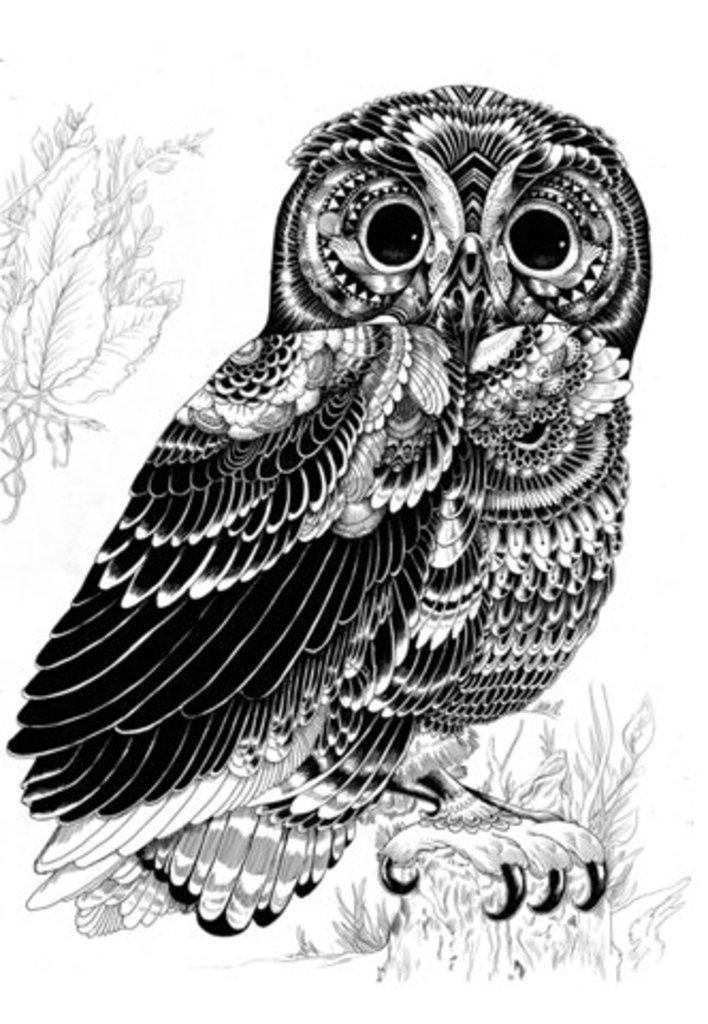Please provide a concise description of this image. In this image I can see an owl art and I can see leaves and flower art visible beside the owl. 